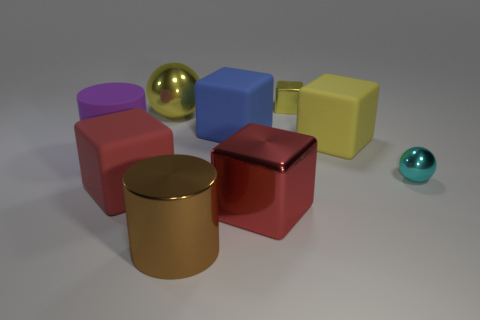What number of blue rubber things are to the right of the brown cylinder? 1 